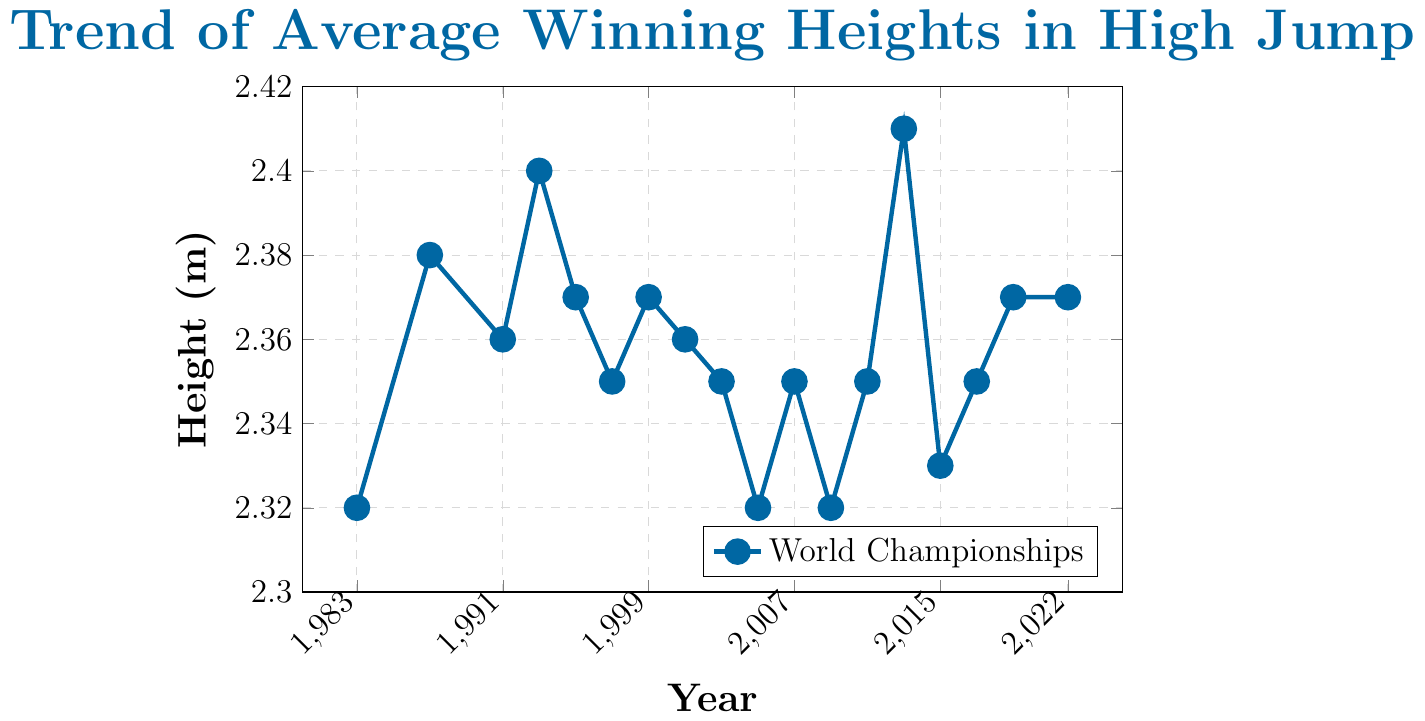What's the average winning height between 1983 and 2022? Sum the heights from 1983 to 2022 and divide by the number of years. (2.32+2.38+2.36+2.40+2.37+2.35+2.37+2.36+2.35+2.32+2.35+2.32+2.35+2.41+2.33+2.35+2.37+2.37)/18 ≈ 2.353
Answer: 2.353 meters What was the year with the highest average winning height? Identify the highest point on the line chart and note the corresponding year. The highest point is at 2.41 meters in 2013.
Answer: 2013 How many times did the average winning height reach 2.38 meters or higher? Count the number of data points that meet or exceed 2.38 meters. There are 4 such years: 1987, 1993, 2013, 2013.
Answer: 4 Which years saw a decline in the average winning height compared to the previous event? Identify the years where the height decreases from the previous year. The years are 1991, 1997, 2001, 2005, 2009, 2015.
Answer: 1991, 1997, 2001, 2005, 2009, 2015 What is the approximate trend in the data from 1983 to 2022? Observe the overall pattern of the line chart. The trend shows fluctuations with a slight overall increase from 2.32 meters to a peak at 2.41 meters in 2013, ending at 2.37 meters in 2022.
Answer: Fluctuating with a slight upward trend Compare the average winning height between the first decade (1983-1993) and the most recent decade (2012-2022). Which period has a higher average height? Calculate the average for both periods and compare. First decade (2.32+2.38+2.36+2.40)/4 = 2.365 meters. Recent decade (2.41+2.33+2.35+2.37+2.37)/5 = 2.366 meters.
Answer: Recent decade What is the range of the average winning heights in the dataset? Subtract the smallest value from the largest value in the dataset. Highest value: 2.41 meters, lowest value: 2.32 meters. Range = 2.41 - 2.32 = 0.09 meters.
Answer: 0.09 meters Which year had a similar average winning height to 2001? Identify the year(s) whose winning height matches or is close to 2.36 meters. The same heights occur in 1991 and 2001.
Answer: 1991 